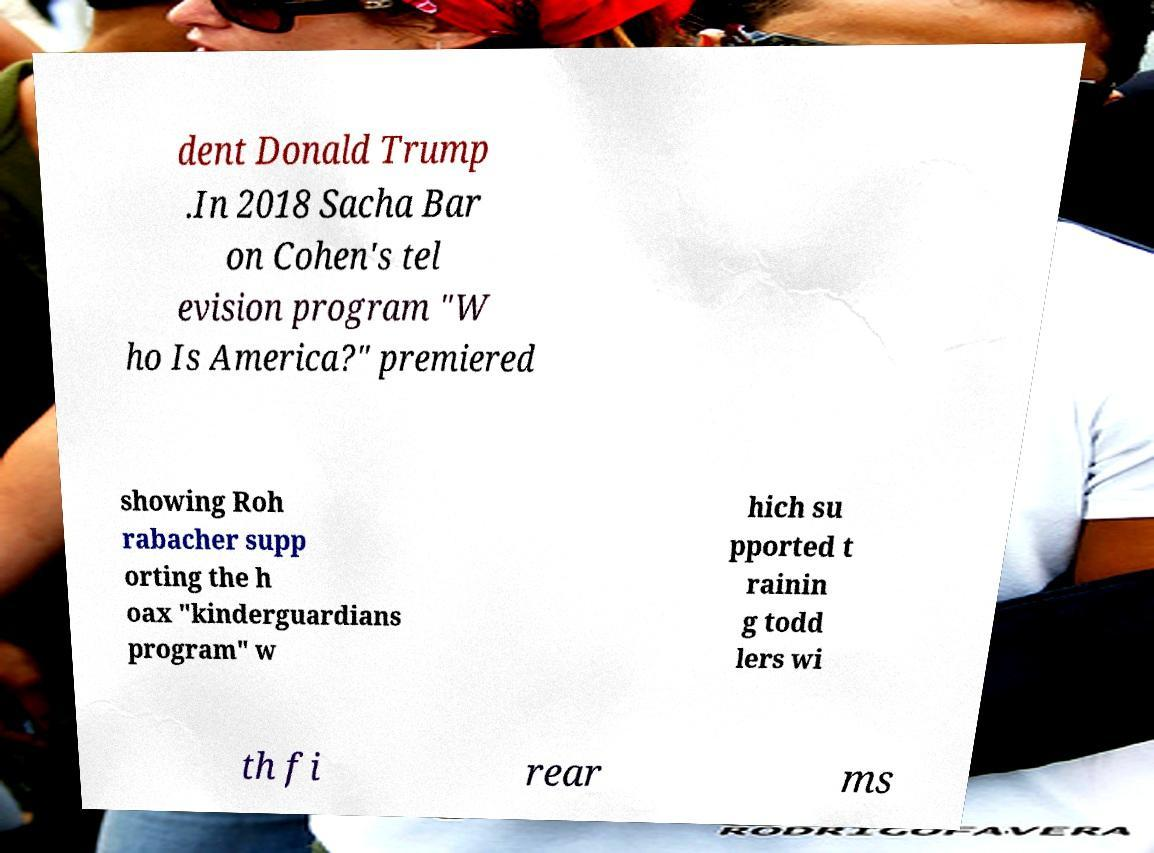Can you read and provide the text displayed in the image?This photo seems to have some interesting text. Can you extract and type it out for me? dent Donald Trump .In 2018 Sacha Bar on Cohen's tel evision program "W ho Is America?" premiered showing Roh rabacher supp orting the h oax "kinderguardians program" w hich su pported t rainin g todd lers wi th fi rear ms 